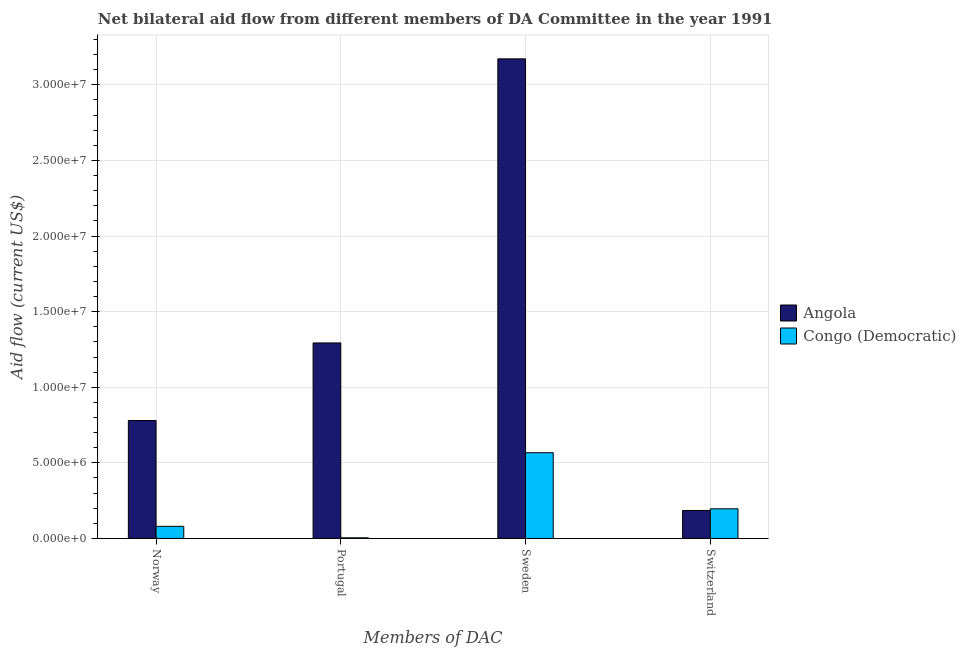How many different coloured bars are there?
Give a very brief answer. 2. How many groups of bars are there?
Make the answer very short. 4. Are the number of bars per tick equal to the number of legend labels?
Offer a very short reply. Yes. Are the number of bars on each tick of the X-axis equal?
Provide a succinct answer. Yes. How many bars are there on the 1st tick from the left?
Give a very brief answer. 2. How many bars are there on the 2nd tick from the right?
Offer a very short reply. 2. What is the amount of aid given by sweden in Congo (Democratic)?
Provide a succinct answer. 5.67e+06. Across all countries, what is the maximum amount of aid given by norway?
Offer a terse response. 7.80e+06. Across all countries, what is the minimum amount of aid given by sweden?
Offer a terse response. 5.67e+06. In which country was the amount of aid given by norway maximum?
Your answer should be compact. Angola. In which country was the amount of aid given by sweden minimum?
Ensure brevity in your answer.  Congo (Democratic). What is the total amount of aid given by switzerland in the graph?
Offer a very short reply. 3.81e+06. What is the difference between the amount of aid given by norway in Angola and that in Congo (Democratic)?
Ensure brevity in your answer.  7.00e+06. What is the difference between the amount of aid given by sweden in Angola and the amount of aid given by norway in Congo (Democratic)?
Ensure brevity in your answer.  3.09e+07. What is the average amount of aid given by sweden per country?
Provide a succinct answer. 1.87e+07. What is the difference between the amount of aid given by norway and amount of aid given by switzerland in Angola?
Make the answer very short. 5.95e+06. What is the ratio of the amount of aid given by portugal in Congo (Democratic) to that in Angola?
Your answer should be very brief. 0. What is the difference between the highest and the second highest amount of aid given by portugal?
Keep it short and to the point. 1.29e+07. What is the difference between the highest and the lowest amount of aid given by portugal?
Ensure brevity in your answer.  1.29e+07. In how many countries, is the amount of aid given by portugal greater than the average amount of aid given by portugal taken over all countries?
Give a very brief answer. 1. Is it the case that in every country, the sum of the amount of aid given by sweden and amount of aid given by switzerland is greater than the sum of amount of aid given by portugal and amount of aid given by norway?
Offer a very short reply. No. What does the 2nd bar from the left in Switzerland represents?
Make the answer very short. Congo (Democratic). What does the 2nd bar from the right in Portugal represents?
Ensure brevity in your answer.  Angola. Are all the bars in the graph horizontal?
Your answer should be compact. No. How many countries are there in the graph?
Provide a succinct answer. 2. What is the difference between two consecutive major ticks on the Y-axis?
Your response must be concise. 5.00e+06. Are the values on the major ticks of Y-axis written in scientific E-notation?
Make the answer very short. Yes. Does the graph contain any zero values?
Provide a short and direct response. No. How many legend labels are there?
Give a very brief answer. 2. How are the legend labels stacked?
Keep it short and to the point. Vertical. What is the title of the graph?
Your answer should be compact. Net bilateral aid flow from different members of DA Committee in the year 1991. What is the label or title of the X-axis?
Provide a succinct answer. Members of DAC. What is the Aid flow (current US$) of Angola in Norway?
Give a very brief answer. 7.80e+06. What is the Aid flow (current US$) of Congo (Democratic) in Norway?
Offer a terse response. 8.00e+05. What is the Aid flow (current US$) in Angola in Portugal?
Offer a very short reply. 1.29e+07. What is the Aid flow (current US$) of Congo (Democratic) in Portugal?
Give a very brief answer. 4.00e+04. What is the Aid flow (current US$) in Angola in Sweden?
Offer a terse response. 3.17e+07. What is the Aid flow (current US$) in Congo (Democratic) in Sweden?
Offer a terse response. 5.67e+06. What is the Aid flow (current US$) of Angola in Switzerland?
Keep it short and to the point. 1.85e+06. What is the Aid flow (current US$) of Congo (Democratic) in Switzerland?
Your answer should be compact. 1.96e+06. Across all Members of DAC, what is the maximum Aid flow (current US$) of Angola?
Your answer should be compact. 3.17e+07. Across all Members of DAC, what is the maximum Aid flow (current US$) in Congo (Democratic)?
Provide a succinct answer. 5.67e+06. Across all Members of DAC, what is the minimum Aid flow (current US$) of Angola?
Make the answer very short. 1.85e+06. Across all Members of DAC, what is the minimum Aid flow (current US$) of Congo (Democratic)?
Ensure brevity in your answer.  4.00e+04. What is the total Aid flow (current US$) in Angola in the graph?
Offer a terse response. 5.43e+07. What is the total Aid flow (current US$) of Congo (Democratic) in the graph?
Offer a very short reply. 8.47e+06. What is the difference between the Aid flow (current US$) of Angola in Norway and that in Portugal?
Give a very brief answer. -5.13e+06. What is the difference between the Aid flow (current US$) in Congo (Democratic) in Norway and that in Portugal?
Ensure brevity in your answer.  7.60e+05. What is the difference between the Aid flow (current US$) in Angola in Norway and that in Sweden?
Provide a short and direct response. -2.39e+07. What is the difference between the Aid flow (current US$) of Congo (Democratic) in Norway and that in Sweden?
Keep it short and to the point. -4.87e+06. What is the difference between the Aid flow (current US$) of Angola in Norway and that in Switzerland?
Provide a short and direct response. 5.95e+06. What is the difference between the Aid flow (current US$) of Congo (Democratic) in Norway and that in Switzerland?
Provide a short and direct response. -1.16e+06. What is the difference between the Aid flow (current US$) of Angola in Portugal and that in Sweden?
Your answer should be compact. -1.88e+07. What is the difference between the Aid flow (current US$) in Congo (Democratic) in Portugal and that in Sweden?
Ensure brevity in your answer.  -5.63e+06. What is the difference between the Aid flow (current US$) in Angola in Portugal and that in Switzerland?
Give a very brief answer. 1.11e+07. What is the difference between the Aid flow (current US$) of Congo (Democratic) in Portugal and that in Switzerland?
Offer a terse response. -1.92e+06. What is the difference between the Aid flow (current US$) in Angola in Sweden and that in Switzerland?
Offer a very short reply. 2.99e+07. What is the difference between the Aid flow (current US$) of Congo (Democratic) in Sweden and that in Switzerland?
Give a very brief answer. 3.71e+06. What is the difference between the Aid flow (current US$) in Angola in Norway and the Aid flow (current US$) in Congo (Democratic) in Portugal?
Offer a very short reply. 7.76e+06. What is the difference between the Aid flow (current US$) of Angola in Norway and the Aid flow (current US$) of Congo (Democratic) in Sweden?
Your response must be concise. 2.13e+06. What is the difference between the Aid flow (current US$) of Angola in Norway and the Aid flow (current US$) of Congo (Democratic) in Switzerland?
Your answer should be very brief. 5.84e+06. What is the difference between the Aid flow (current US$) in Angola in Portugal and the Aid flow (current US$) in Congo (Democratic) in Sweden?
Your response must be concise. 7.26e+06. What is the difference between the Aid flow (current US$) of Angola in Portugal and the Aid flow (current US$) of Congo (Democratic) in Switzerland?
Your answer should be very brief. 1.10e+07. What is the difference between the Aid flow (current US$) in Angola in Sweden and the Aid flow (current US$) in Congo (Democratic) in Switzerland?
Provide a short and direct response. 2.98e+07. What is the average Aid flow (current US$) in Angola per Members of DAC?
Make the answer very short. 1.36e+07. What is the average Aid flow (current US$) of Congo (Democratic) per Members of DAC?
Ensure brevity in your answer.  2.12e+06. What is the difference between the Aid flow (current US$) of Angola and Aid flow (current US$) of Congo (Democratic) in Portugal?
Offer a terse response. 1.29e+07. What is the difference between the Aid flow (current US$) in Angola and Aid flow (current US$) in Congo (Democratic) in Sweden?
Provide a succinct answer. 2.60e+07. What is the difference between the Aid flow (current US$) of Angola and Aid flow (current US$) of Congo (Democratic) in Switzerland?
Offer a very short reply. -1.10e+05. What is the ratio of the Aid flow (current US$) in Angola in Norway to that in Portugal?
Offer a terse response. 0.6. What is the ratio of the Aid flow (current US$) of Angola in Norway to that in Sweden?
Ensure brevity in your answer.  0.25. What is the ratio of the Aid flow (current US$) of Congo (Democratic) in Norway to that in Sweden?
Keep it short and to the point. 0.14. What is the ratio of the Aid flow (current US$) of Angola in Norway to that in Switzerland?
Provide a succinct answer. 4.22. What is the ratio of the Aid flow (current US$) of Congo (Democratic) in Norway to that in Switzerland?
Your answer should be compact. 0.41. What is the ratio of the Aid flow (current US$) in Angola in Portugal to that in Sweden?
Offer a terse response. 0.41. What is the ratio of the Aid flow (current US$) in Congo (Democratic) in Portugal to that in Sweden?
Ensure brevity in your answer.  0.01. What is the ratio of the Aid flow (current US$) in Angola in Portugal to that in Switzerland?
Your answer should be compact. 6.99. What is the ratio of the Aid flow (current US$) in Congo (Democratic) in Portugal to that in Switzerland?
Ensure brevity in your answer.  0.02. What is the ratio of the Aid flow (current US$) of Angola in Sweden to that in Switzerland?
Provide a succinct answer. 17.15. What is the ratio of the Aid flow (current US$) in Congo (Democratic) in Sweden to that in Switzerland?
Make the answer very short. 2.89. What is the difference between the highest and the second highest Aid flow (current US$) in Angola?
Your response must be concise. 1.88e+07. What is the difference between the highest and the second highest Aid flow (current US$) of Congo (Democratic)?
Provide a short and direct response. 3.71e+06. What is the difference between the highest and the lowest Aid flow (current US$) of Angola?
Your response must be concise. 2.99e+07. What is the difference between the highest and the lowest Aid flow (current US$) of Congo (Democratic)?
Ensure brevity in your answer.  5.63e+06. 